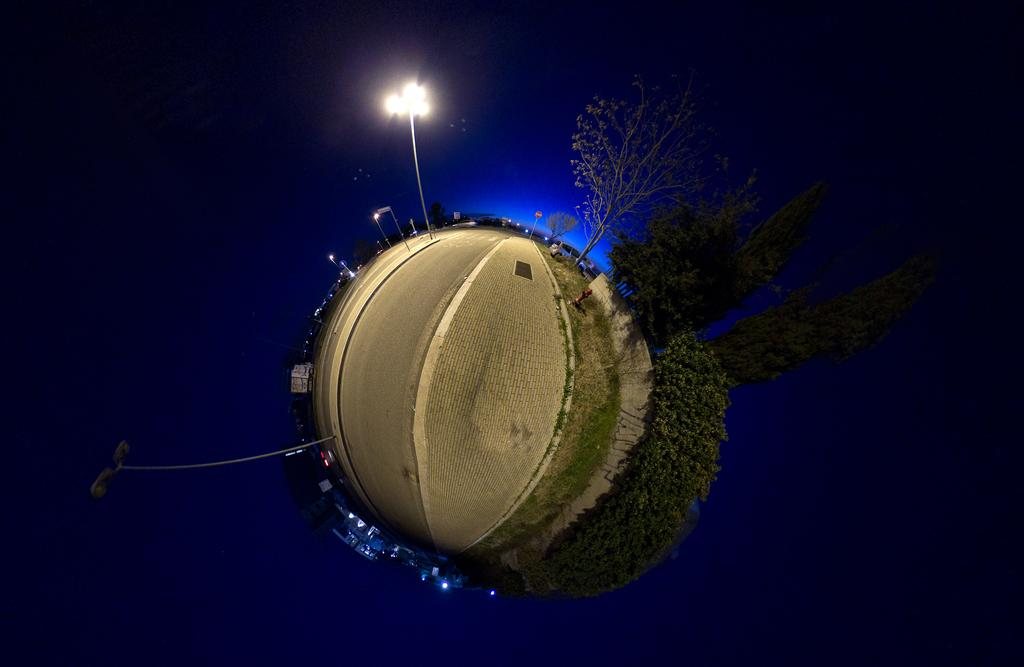What type of view is shown in the image? The image is an aerial view. What structures can be seen in the image? There are buildings in the image. What type of natural elements are present in the image? There are trees in the image. What type of artificial lighting is visible in the image? There are lights in the image. What type of vertical structures are present in the image? There are poles in the image. What type of transportation is visible in the image? There are vehicles on the road in the image. What type of living organisms are present on the ground in the image? There are people on the ground in the image. What is the color of the background in the image? The background color is blue. What type of instrument is being played by the goat in the image? There is no goat or instrument present in the image. What type of guitar is being played by the person on the ground in the image? There is no guitar or person playing a guitar present in the image. 